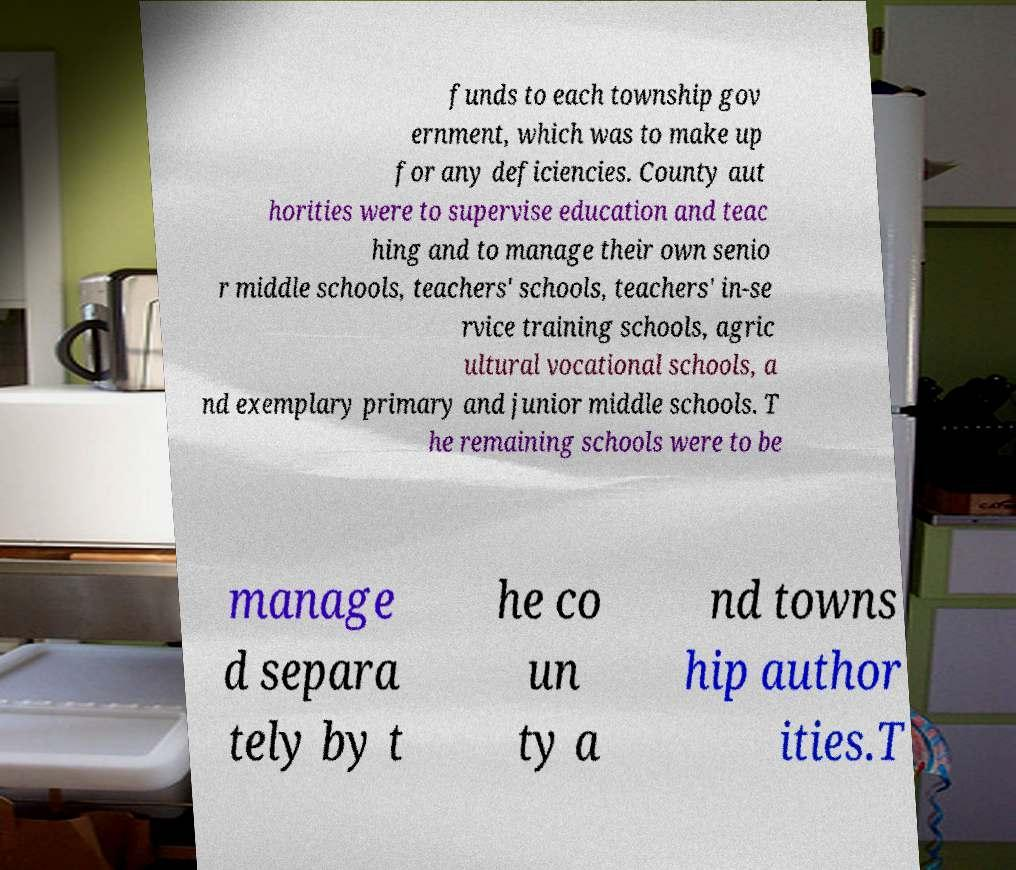What messages or text are displayed in this image? I need them in a readable, typed format. funds to each township gov ernment, which was to make up for any deficiencies. County aut horities were to supervise education and teac hing and to manage their own senio r middle schools, teachers' schools, teachers' in-se rvice training schools, agric ultural vocational schools, a nd exemplary primary and junior middle schools. T he remaining schools were to be manage d separa tely by t he co un ty a nd towns hip author ities.T 